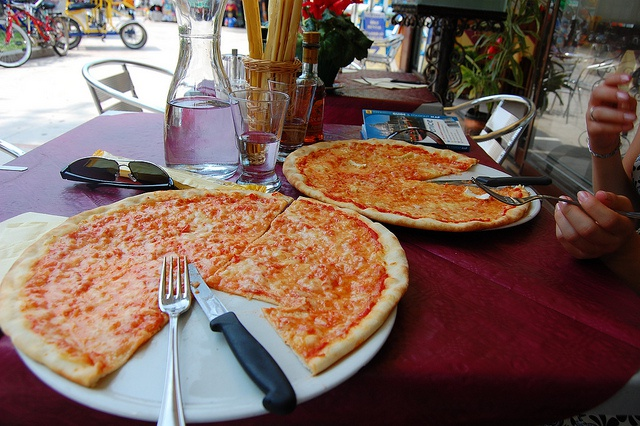Describe the objects in this image and their specific colors. I can see dining table in black, maroon, red, and darkgray tones, pizza in black, tan, red, and lightgray tones, pizza in black, red, and tan tones, pizza in black, red, tan, and brown tones, and people in black, maroon, and brown tones in this image. 